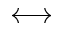Convert formula to latex. <formula><loc_0><loc_0><loc_500><loc_500>\longleftrightarrow</formula> 